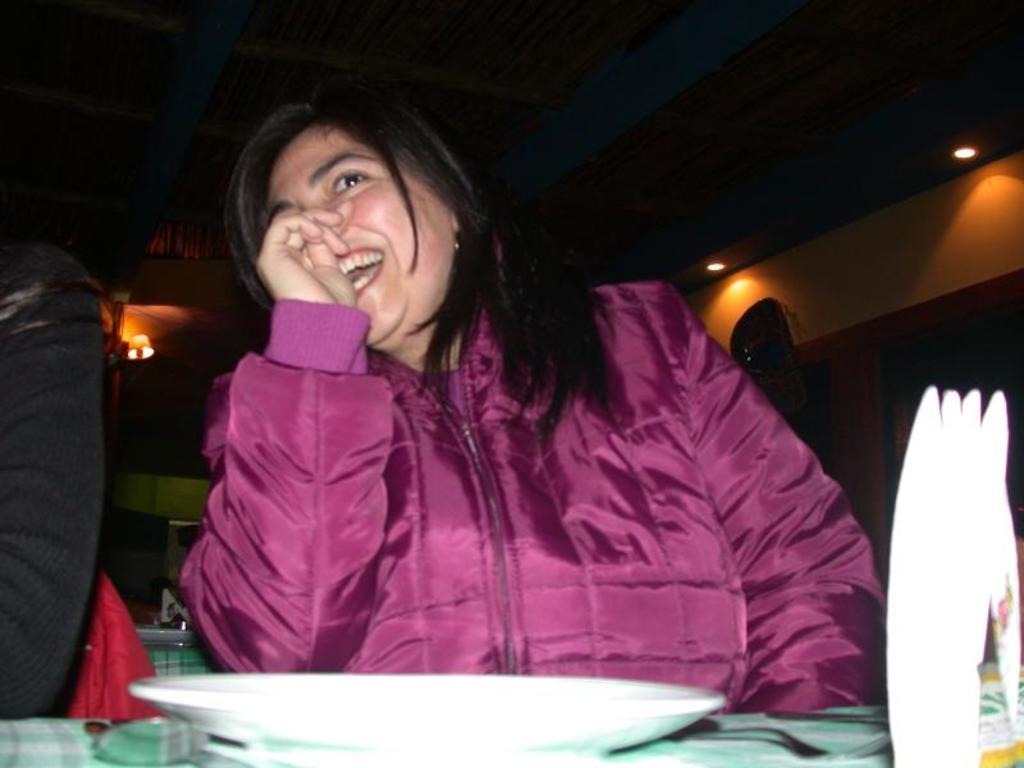Who is the main subject in the image? There is a woman in the image. What is the woman wearing? The woman is wearing a red jacket. What is the woman's facial expression? The woman is smiling. Where is the woman sitting in the image? The woman is sitting in front of a table. What can be seen on the table in the image? There is a white plate on the table. How many lizards are crawling on the woman's red jacket in the image? There are no lizards present in the image, so it is not possible to determine how many might be crawling on the woman's red jacket. 